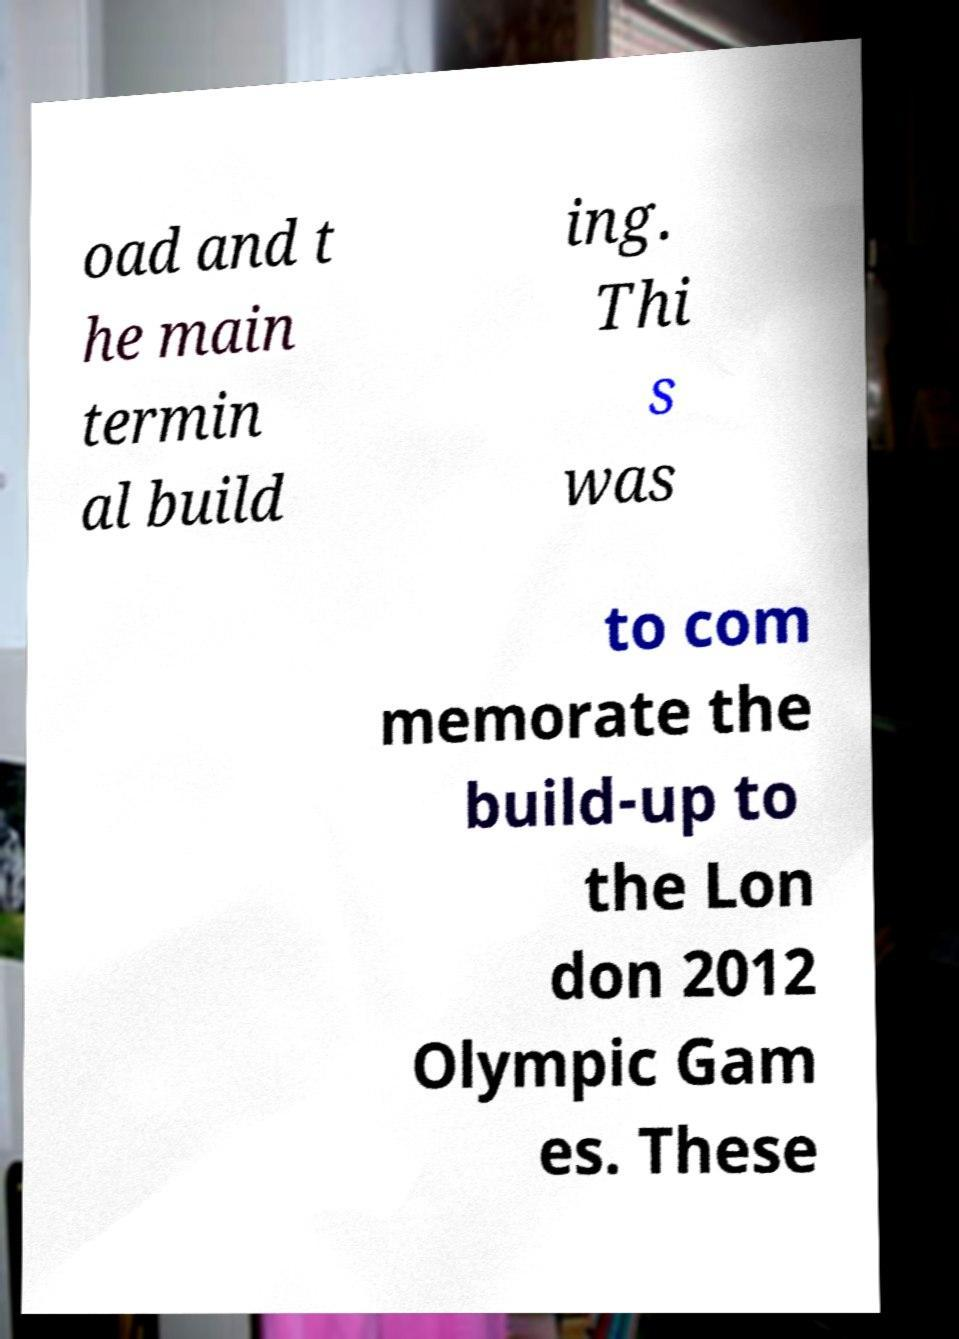What messages or text are displayed in this image? I need them in a readable, typed format. oad and t he main termin al build ing. Thi s was to com memorate the build-up to the Lon don 2012 Olympic Gam es. These 